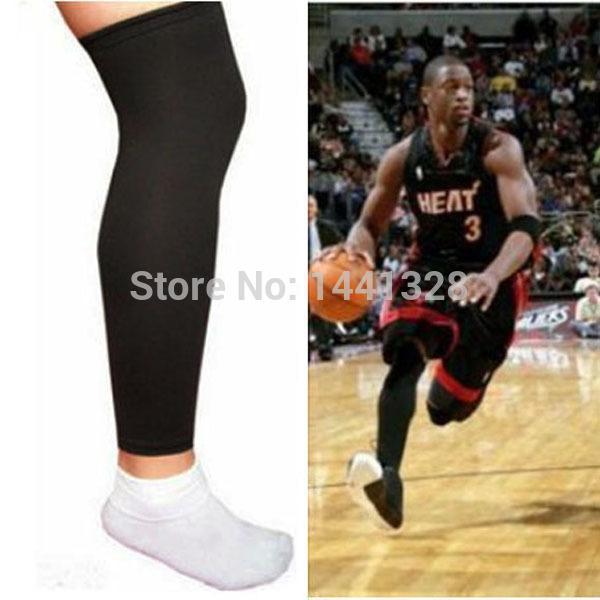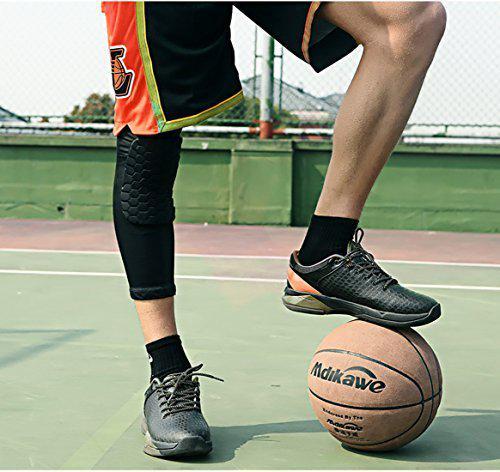The first image is the image on the left, the second image is the image on the right. For the images shown, is this caption "The left and right image contains a total of seven knee braces." true? Answer yes or no. No. 